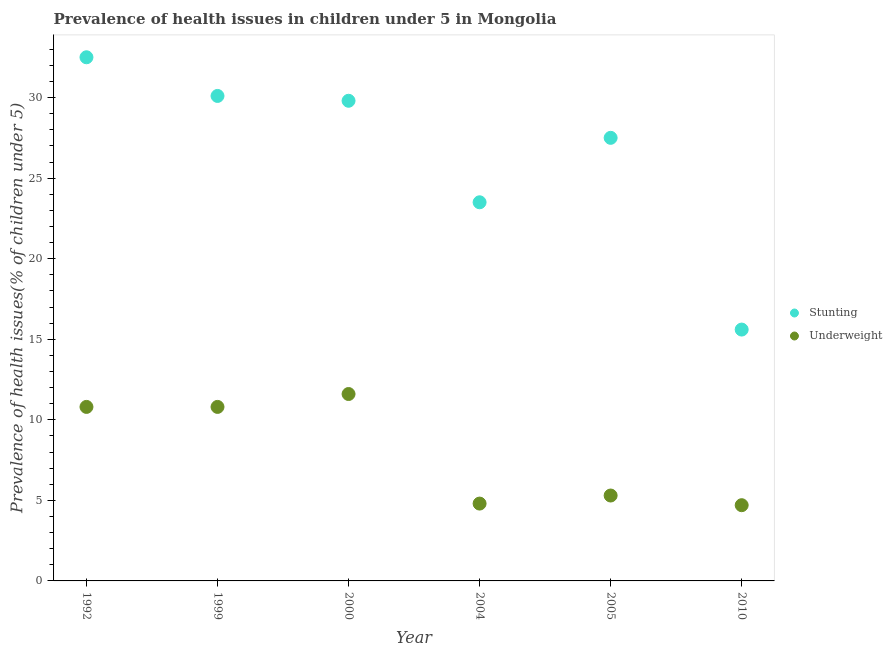What is the percentage of underweight children in 2000?
Your response must be concise. 11.6. Across all years, what is the maximum percentage of underweight children?
Provide a succinct answer. 11.6. Across all years, what is the minimum percentage of underweight children?
Your answer should be very brief. 4.7. In which year was the percentage of stunted children maximum?
Make the answer very short. 1992. What is the total percentage of stunted children in the graph?
Your response must be concise. 159. What is the difference between the percentage of stunted children in 2010 and the percentage of underweight children in 2005?
Your response must be concise. 10.3. What is the average percentage of underweight children per year?
Make the answer very short. 8. In the year 1999, what is the difference between the percentage of stunted children and percentage of underweight children?
Offer a terse response. 19.3. What is the ratio of the percentage of underweight children in 1992 to that in 2000?
Provide a succinct answer. 0.93. Is the difference between the percentage of underweight children in 1992 and 2004 greater than the difference between the percentage of stunted children in 1992 and 2004?
Give a very brief answer. No. What is the difference between the highest and the second highest percentage of stunted children?
Ensure brevity in your answer.  2.4. What is the difference between the highest and the lowest percentage of underweight children?
Your answer should be compact. 6.9. Is the sum of the percentage of underweight children in 2005 and 2010 greater than the maximum percentage of stunted children across all years?
Offer a terse response. No. Does the percentage of underweight children monotonically increase over the years?
Your answer should be compact. No. Is the percentage of stunted children strictly greater than the percentage of underweight children over the years?
Provide a succinct answer. Yes. How many years are there in the graph?
Ensure brevity in your answer.  6. What is the difference between two consecutive major ticks on the Y-axis?
Offer a very short reply. 5. Are the values on the major ticks of Y-axis written in scientific E-notation?
Your response must be concise. No. Does the graph contain any zero values?
Make the answer very short. No. How are the legend labels stacked?
Your response must be concise. Vertical. What is the title of the graph?
Your answer should be compact. Prevalence of health issues in children under 5 in Mongolia. What is the label or title of the X-axis?
Provide a succinct answer. Year. What is the label or title of the Y-axis?
Provide a succinct answer. Prevalence of health issues(% of children under 5). What is the Prevalence of health issues(% of children under 5) in Stunting in 1992?
Provide a short and direct response. 32.5. What is the Prevalence of health issues(% of children under 5) of Underweight in 1992?
Offer a terse response. 10.8. What is the Prevalence of health issues(% of children under 5) in Stunting in 1999?
Make the answer very short. 30.1. What is the Prevalence of health issues(% of children under 5) of Underweight in 1999?
Give a very brief answer. 10.8. What is the Prevalence of health issues(% of children under 5) of Stunting in 2000?
Provide a short and direct response. 29.8. What is the Prevalence of health issues(% of children under 5) in Underweight in 2000?
Your answer should be compact. 11.6. What is the Prevalence of health issues(% of children under 5) of Stunting in 2004?
Give a very brief answer. 23.5. What is the Prevalence of health issues(% of children under 5) in Underweight in 2004?
Your answer should be very brief. 4.8. What is the Prevalence of health issues(% of children under 5) of Underweight in 2005?
Your response must be concise. 5.3. What is the Prevalence of health issues(% of children under 5) of Stunting in 2010?
Offer a terse response. 15.6. What is the Prevalence of health issues(% of children under 5) in Underweight in 2010?
Make the answer very short. 4.7. Across all years, what is the maximum Prevalence of health issues(% of children under 5) of Stunting?
Your answer should be very brief. 32.5. Across all years, what is the maximum Prevalence of health issues(% of children under 5) of Underweight?
Make the answer very short. 11.6. Across all years, what is the minimum Prevalence of health issues(% of children under 5) of Stunting?
Provide a succinct answer. 15.6. Across all years, what is the minimum Prevalence of health issues(% of children under 5) in Underweight?
Offer a terse response. 4.7. What is the total Prevalence of health issues(% of children under 5) of Stunting in the graph?
Your answer should be very brief. 159. What is the difference between the Prevalence of health issues(% of children under 5) in Stunting in 1992 and that in 1999?
Offer a terse response. 2.4. What is the difference between the Prevalence of health issues(% of children under 5) in Stunting in 1992 and that in 2000?
Offer a very short reply. 2.7. What is the difference between the Prevalence of health issues(% of children under 5) in Stunting in 1992 and that in 2004?
Provide a succinct answer. 9. What is the difference between the Prevalence of health issues(% of children under 5) in Stunting in 1992 and that in 2010?
Your answer should be compact. 16.9. What is the difference between the Prevalence of health issues(% of children under 5) in Underweight in 1992 and that in 2010?
Ensure brevity in your answer.  6.1. What is the difference between the Prevalence of health issues(% of children under 5) in Stunting in 1999 and that in 2004?
Your answer should be compact. 6.6. What is the difference between the Prevalence of health issues(% of children under 5) of Underweight in 1999 and that in 2004?
Ensure brevity in your answer.  6. What is the difference between the Prevalence of health issues(% of children under 5) in Stunting in 1999 and that in 2005?
Ensure brevity in your answer.  2.6. What is the difference between the Prevalence of health issues(% of children under 5) in Stunting in 2000 and that in 2005?
Your response must be concise. 2.3. What is the difference between the Prevalence of health issues(% of children under 5) of Stunting in 2000 and that in 2010?
Make the answer very short. 14.2. What is the difference between the Prevalence of health issues(% of children under 5) in Stunting in 2004 and that in 2005?
Offer a terse response. -4. What is the difference between the Prevalence of health issues(% of children under 5) of Stunting in 2004 and that in 2010?
Your answer should be compact. 7.9. What is the difference between the Prevalence of health issues(% of children under 5) of Underweight in 2005 and that in 2010?
Give a very brief answer. 0.6. What is the difference between the Prevalence of health issues(% of children under 5) of Stunting in 1992 and the Prevalence of health issues(% of children under 5) of Underweight in 1999?
Ensure brevity in your answer.  21.7. What is the difference between the Prevalence of health issues(% of children under 5) of Stunting in 1992 and the Prevalence of health issues(% of children under 5) of Underweight in 2000?
Your response must be concise. 20.9. What is the difference between the Prevalence of health issues(% of children under 5) of Stunting in 1992 and the Prevalence of health issues(% of children under 5) of Underweight in 2004?
Your answer should be compact. 27.7. What is the difference between the Prevalence of health issues(% of children under 5) of Stunting in 1992 and the Prevalence of health issues(% of children under 5) of Underweight in 2005?
Ensure brevity in your answer.  27.2. What is the difference between the Prevalence of health issues(% of children under 5) in Stunting in 1992 and the Prevalence of health issues(% of children under 5) in Underweight in 2010?
Your answer should be compact. 27.8. What is the difference between the Prevalence of health issues(% of children under 5) in Stunting in 1999 and the Prevalence of health issues(% of children under 5) in Underweight in 2004?
Keep it short and to the point. 25.3. What is the difference between the Prevalence of health issues(% of children under 5) of Stunting in 1999 and the Prevalence of health issues(% of children under 5) of Underweight in 2005?
Your answer should be compact. 24.8. What is the difference between the Prevalence of health issues(% of children under 5) in Stunting in 1999 and the Prevalence of health issues(% of children under 5) in Underweight in 2010?
Your response must be concise. 25.4. What is the difference between the Prevalence of health issues(% of children under 5) in Stunting in 2000 and the Prevalence of health issues(% of children under 5) in Underweight in 2010?
Your answer should be very brief. 25.1. What is the difference between the Prevalence of health issues(% of children under 5) of Stunting in 2004 and the Prevalence of health issues(% of children under 5) of Underweight in 2005?
Your answer should be very brief. 18.2. What is the difference between the Prevalence of health issues(% of children under 5) of Stunting in 2004 and the Prevalence of health issues(% of children under 5) of Underweight in 2010?
Make the answer very short. 18.8. What is the difference between the Prevalence of health issues(% of children under 5) of Stunting in 2005 and the Prevalence of health issues(% of children under 5) of Underweight in 2010?
Provide a succinct answer. 22.8. What is the average Prevalence of health issues(% of children under 5) in Underweight per year?
Your answer should be very brief. 8. In the year 1992, what is the difference between the Prevalence of health issues(% of children under 5) in Stunting and Prevalence of health issues(% of children under 5) in Underweight?
Your answer should be compact. 21.7. In the year 1999, what is the difference between the Prevalence of health issues(% of children under 5) in Stunting and Prevalence of health issues(% of children under 5) in Underweight?
Your answer should be compact. 19.3. In the year 2000, what is the difference between the Prevalence of health issues(% of children under 5) in Stunting and Prevalence of health issues(% of children under 5) in Underweight?
Make the answer very short. 18.2. In the year 2004, what is the difference between the Prevalence of health issues(% of children under 5) of Stunting and Prevalence of health issues(% of children under 5) of Underweight?
Ensure brevity in your answer.  18.7. In the year 2010, what is the difference between the Prevalence of health issues(% of children under 5) in Stunting and Prevalence of health issues(% of children under 5) in Underweight?
Provide a succinct answer. 10.9. What is the ratio of the Prevalence of health issues(% of children under 5) of Stunting in 1992 to that in 1999?
Offer a very short reply. 1.08. What is the ratio of the Prevalence of health issues(% of children under 5) of Underweight in 1992 to that in 1999?
Offer a terse response. 1. What is the ratio of the Prevalence of health issues(% of children under 5) of Stunting in 1992 to that in 2000?
Offer a very short reply. 1.09. What is the ratio of the Prevalence of health issues(% of children under 5) of Underweight in 1992 to that in 2000?
Your answer should be very brief. 0.93. What is the ratio of the Prevalence of health issues(% of children under 5) of Stunting in 1992 to that in 2004?
Your answer should be compact. 1.38. What is the ratio of the Prevalence of health issues(% of children under 5) of Underweight in 1992 to that in 2004?
Your answer should be very brief. 2.25. What is the ratio of the Prevalence of health issues(% of children under 5) in Stunting in 1992 to that in 2005?
Offer a very short reply. 1.18. What is the ratio of the Prevalence of health issues(% of children under 5) in Underweight in 1992 to that in 2005?
Your answer should be compact. 2.04. What is the ratio of the Prevalence of health issues(% of children under 5) of Stunting in 1992 to that in 2010?
Your response must be concise. 2.08. What is the ratio of the Prevalence of health issues(% of children under 5) of Underweight in 1992 to that in 2010?
Your response must be concise. 2.3. What is the ratio of the Prevalence of health issues(% of children under 5) of Stunting in 1999 to that in 2000?
Provide a short and direct response. 1.01. What is the ratio of the Prevalence of health issues(% of children under 5) of Underweight in 1999 to that in 2000?
Provide a short and direct response. 0.93. What is the ratio of the Prevalence of health issues(% of children under 5) of Stunting in 1999 to that in 2004?
Provide a short and direct response. 1.28. What is the ratio of the Prevalence of health issues(% of children under 5) of Underweight in 1999 to that in 2004?
Your response must be concise. 2.25. What is the ratio of the Prevalence of health issues(% of children under 5) in Stunting in 1999 to that in 2005?
Your response must be concise. 1.09. What is the ratio of the Prevalence of health issues(% of children under 5) in Underweight in 1999 to that in 2005?
Offer a terse response. 2.04. What is the ratio of the Prevalence of health issues(% of children under 5) of Stunting in 1999 to that in 2010?
Your response must be concise. 1.93. What is the ratio of the Prevalence of health issues(% of children under 5) of Underweight in 1999 to that in 2010?
Give a very brief answer. 2.3. What is the ratio of the Prevalence of health issues(% of children under 5) in Stunting in 2000 to that in 2004?
Keep it short and to the point. 1.27. What is the ratio of the Prevalence of health issues(% of children under 5) in Underweight in 2000 to that in 2004?
Provide a succinct answer. 2.42. What is the ratio of the Prevalence of health issues(% of children under 5) in Stunting in 2000 to that in 2005?
Offer a very short reply. 1.08. What is the ratio of the Prevalence of health issues(% of children under 5) in Underweight in 2000 to that in 2005?
Ensure brevity in your answer.  2.19. What is the ratio of the Prevalence of health issues(% of children under 5) in Stunting in 2000 to that in 2010?
Give a very brief answer. 1.91. What is the ratio of the Prevalence of health issues(% of children under 5) in Underweight in 2000 to that in 2010?
Give a very brief answer. 2.47. What is the ratio of the Prevalence of health issues(% of children under 5) in Stunting in 2004 to that in 2005?
Provide a succinct answer. 0.85. What is the ratio of the Prevalence of health issues(% of children under 5) of Underweight in 2004 to that in 2005?
Provide a short and direct response. 0.91. What is the ratio of the Prevalence of health issues(% of children under 5) of Stunting in 2004 to that in 2010?
Your response must be concise. 1.51. What is the ratio of the Prevalence of health issues(% of children under 5) in Underweight in 2004 to that in 2010?
Your response must be concise. 1.02. What is the ratio of the Prevalence of health issues(% of children under 5) of Stunting in 2005 to that in 2010?
Your response must be concise. 1.76. What is the ratio of the Prevalence of health issues(% of children under 5) in Underweight in 2005 to that in 2010?
Keep it short and to the point. 1.13. What is the difference between the highest and the second highest Prevalence of health issues(% of children under 5) of Stunting?
Your answer should be compact. 2.4. What is the difference between the highest and the second highest Prevalence of health issues(% of children under 5) of Underweight?
Your answer should be compact. 0.8. What is the difference between the highest and the lowest Prevalence of health issues(% of children under 5) in Stunting?
Keep it short and to the point. 16.9. What is the difference between the highest and the lowest Prevalence of health issues(% of children under 5) of Underweight?
Provide a short and direct response. 6.9. 